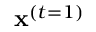<formula> <loc_0><loc_0><loc_500><loc_500>x ^ { ( t = 1 ) }</formula> 